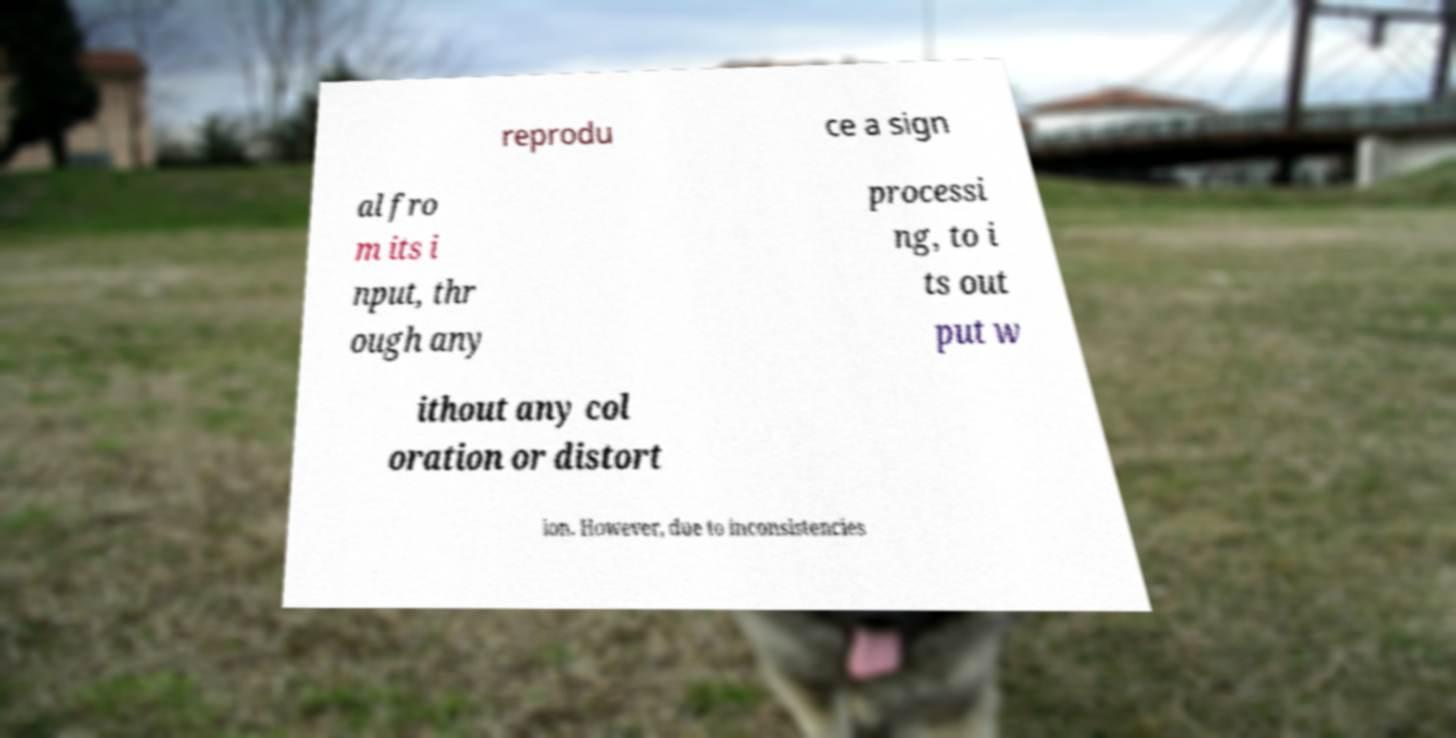I need the written content from this picture converted into text. Can you do that? reprodu ce a sign al fro m its i nput, thr ough any processi ng, to i ts out put w ithout any col oration or distort ion. However, due to inconsistencies 